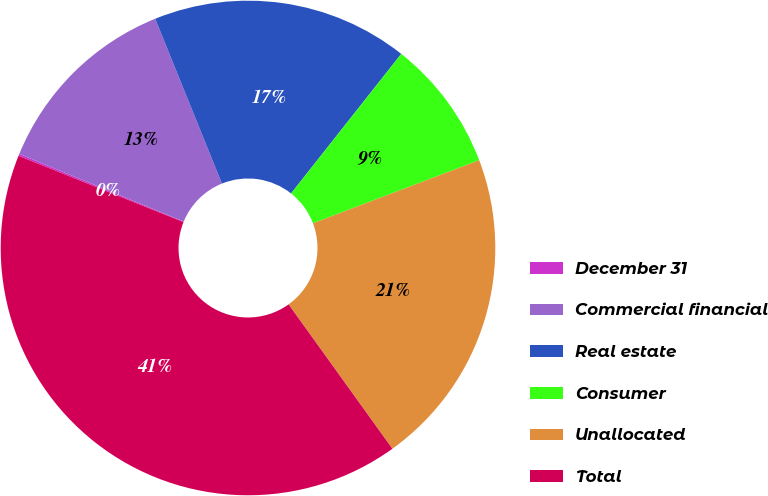Convert chart to OTSL. <chart><loc_0><loc_0><loc_500><loc_500><pie_chart><fcel>December 31<fcel>Commercial financial<fcel>Real estate<fcel>Consumer<fcel>Unallocated<fcel>Total<nl><fcel>0.13%<fcel>12.67%<fcel>16.76%<fcel>8.59%<fcel>20.85%<fcel>41.0%<nl></chart> 